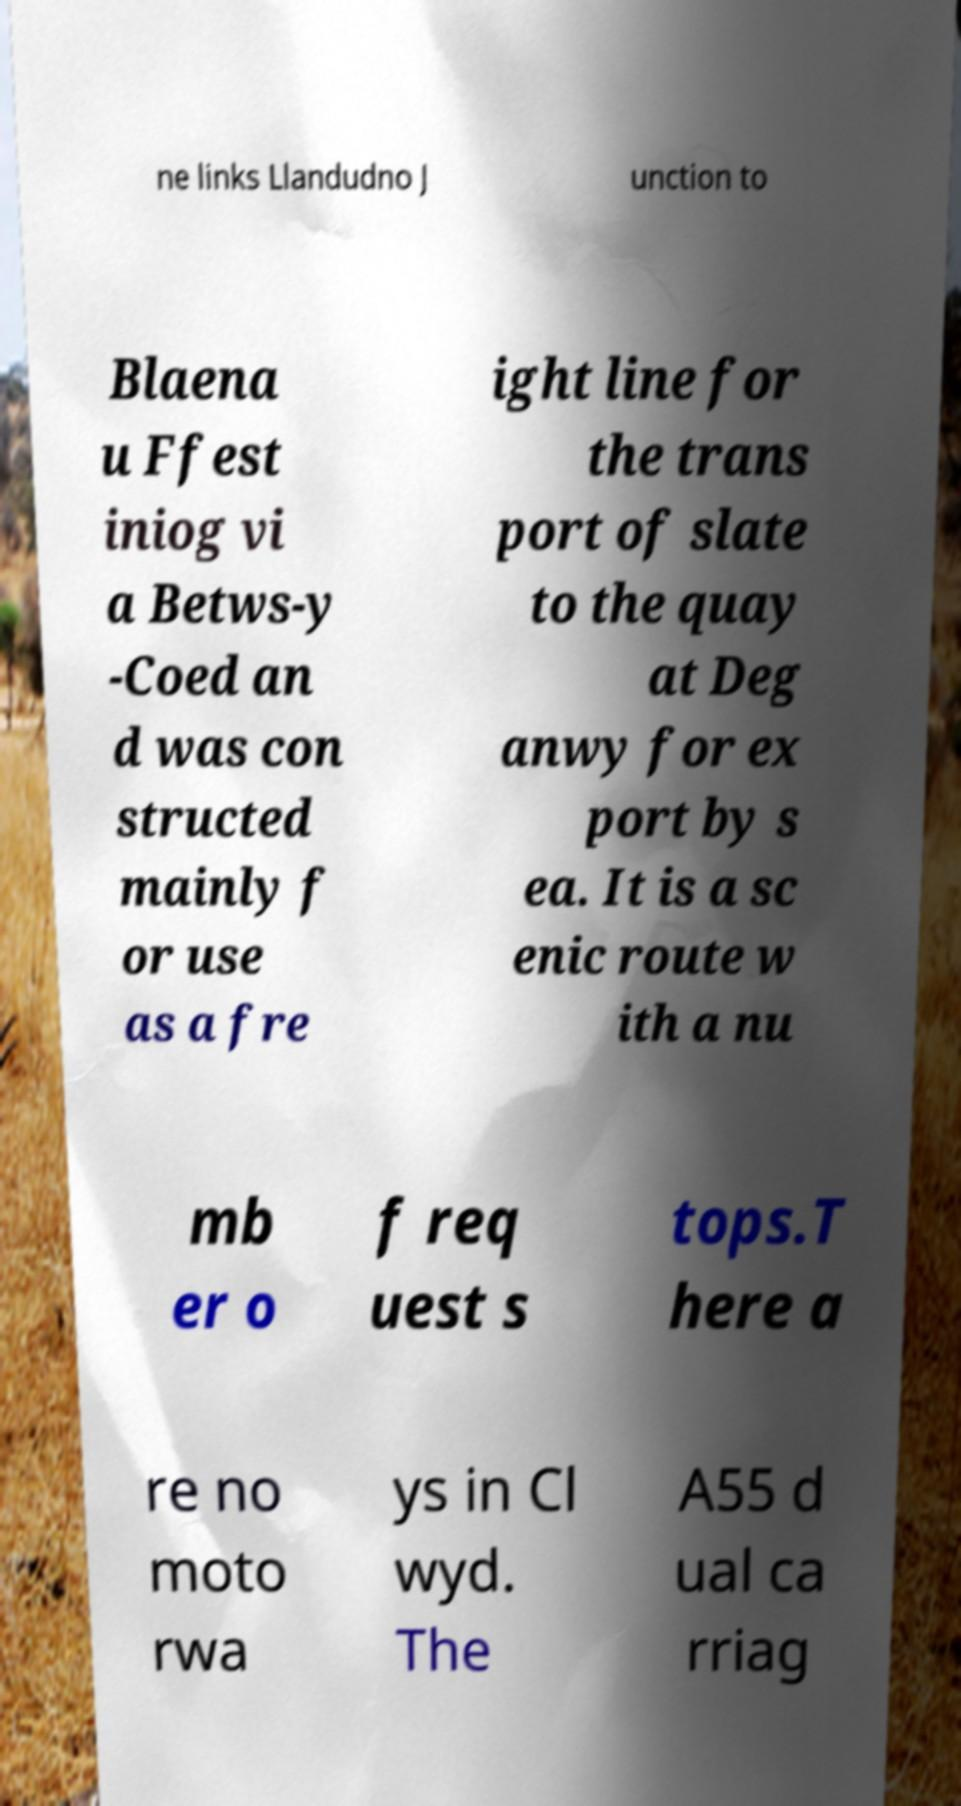Can you accurately transcribe the text from the provided image for me? ne links Llandudno J unction to Blaena u Ffest iniog vi a Betws-y -Coed an d was con structed mainly f or use as a fre ight line for the trans port of slate to the quay at Deg anwy for ex port by s ea. It is a sc enic route w ith a nu mb er o f req uest s tops.T here a re no moto rwa ys in Cl wyd. The A55 d ual ca rriag 